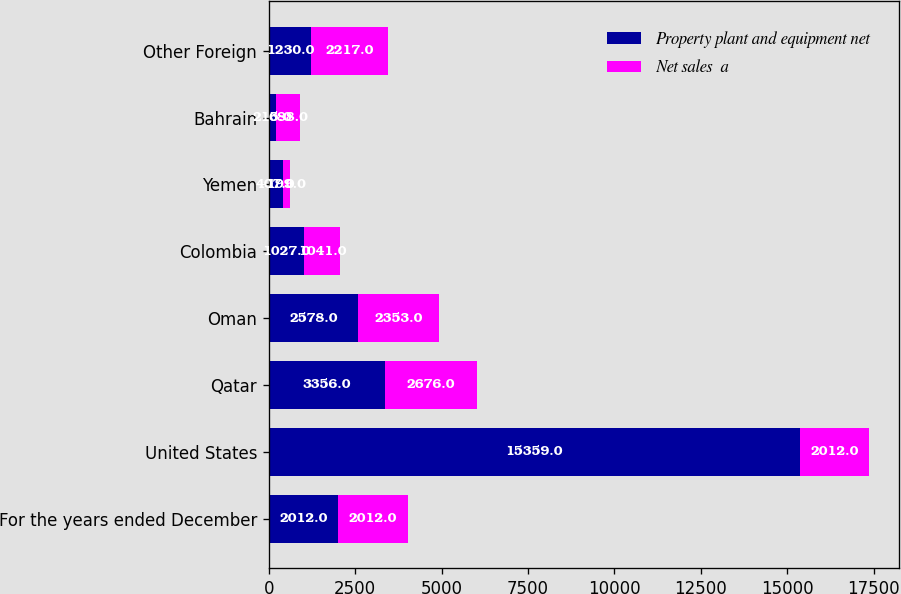Convert chart. <chart><loc_0><loc_0><loc_500><loc_500><stacked_bar_chart><ecel><fcel>For the years ended December<fcel>United States<fcel>Qatar<fcel>Oman<fcel>Colombia<fcel>Yemen<fcel>Bahrain<fcel>Other Foreign<nl><fcel>Property plant and equipment net<fcel>2012<fcel>15359<fcel>3356<fcel>2578<fcel>1027<fcel>407<fcel>215<fcel>1230<nl><fcel>Net sales  a<fcel>2012<fcel>2012<fcel>2676<fcel>2353<fcel>1041<fcel>199<fcel>688<fcel>2217<nl></chart> 